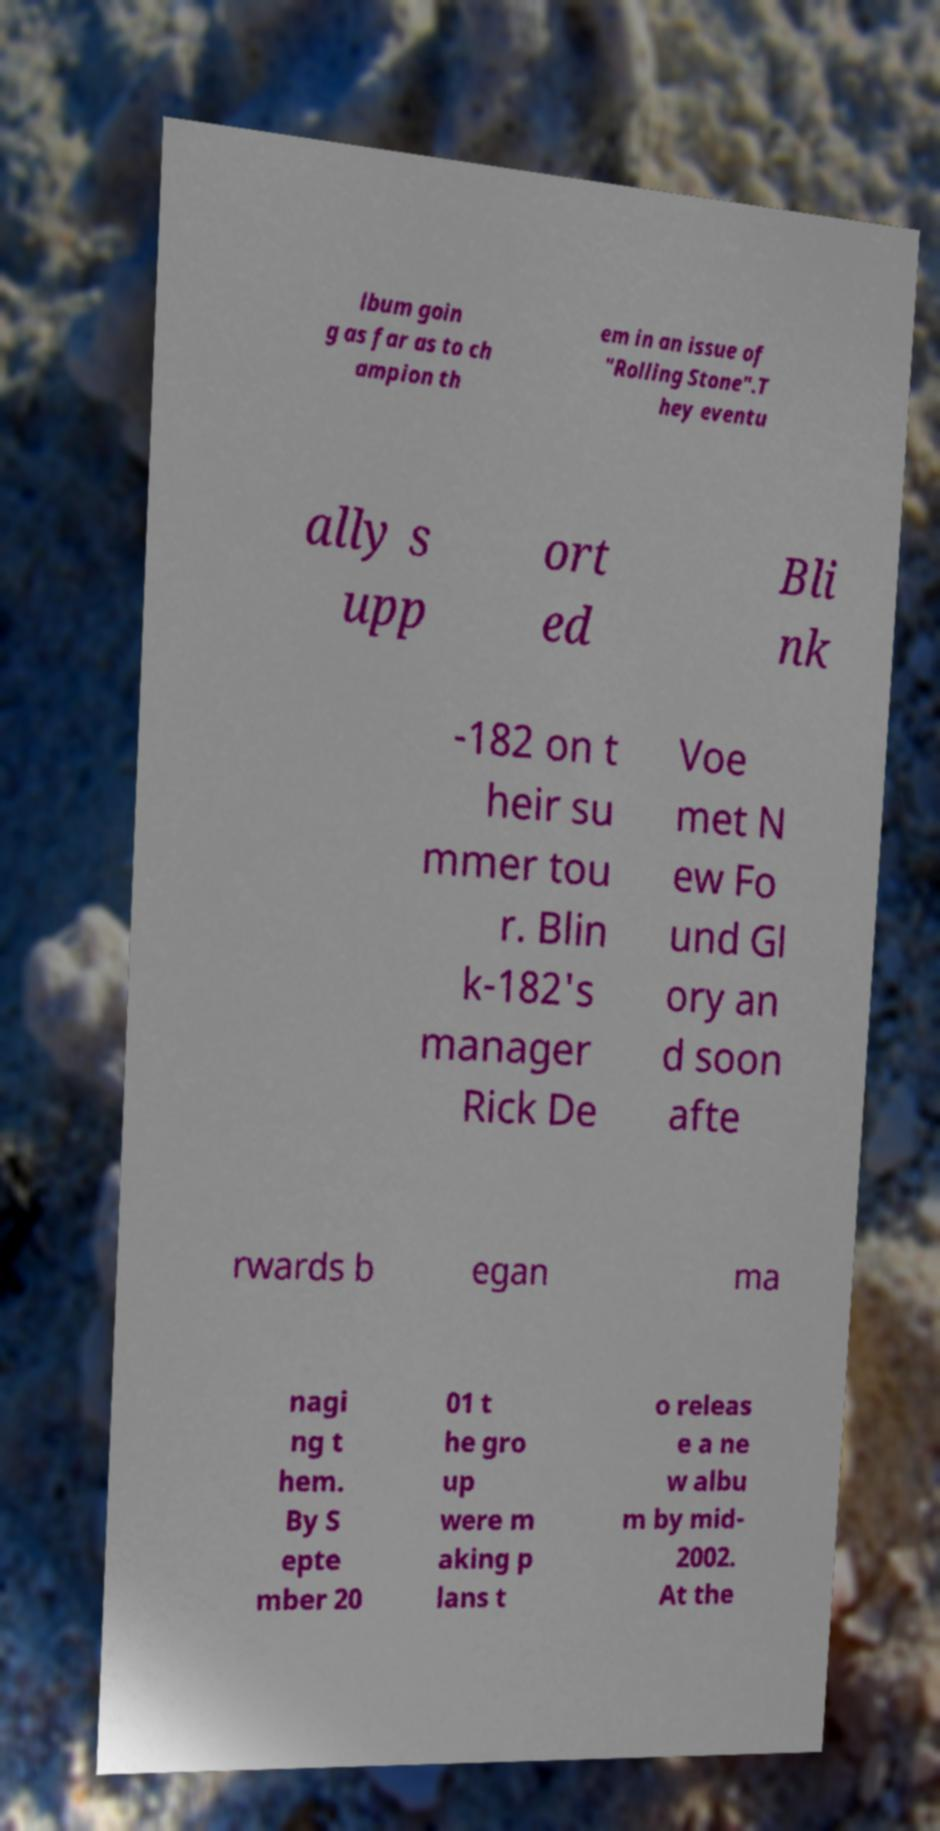Can you accurately transcribe the text from the provided image for me? lbum goin g as far as to ch ampion th em in an issue of "Rolling Stone".T hey eventu ally s upp ort ed Bli nk -182 on t heir su mmer tou r. Blin k-182's manager Rick De Voe met N ew Fo und Gl ory an d soon afte rwards b egan ma nagi ng t hem. By S epte mber 20 01 t he gro up were m aking p lans t o releas e a ne w albu m by mid- 2002. At the 